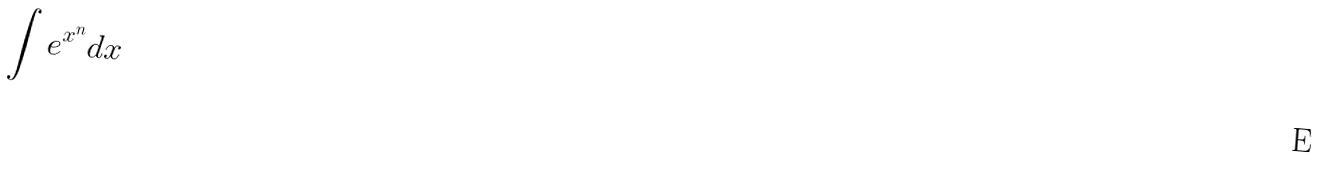Convert formula to latex. <formula><loc_0><loc_0><loc_500><loc_500>\int e ^ { x ^ { n } } d x</formula> 